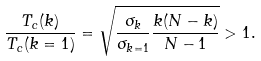<formula> <loc_0><loc_0><loc_500><loc_500>\frac { T _ { c } ( k ) } { T _ { c } ( k = 1 ) } = \sqrt { \frac { \sigma _ { k } } { \sigma _ { k = 1 } } \frac { k ( N - k ) } { N - 1 } } > 1 .</formula> 